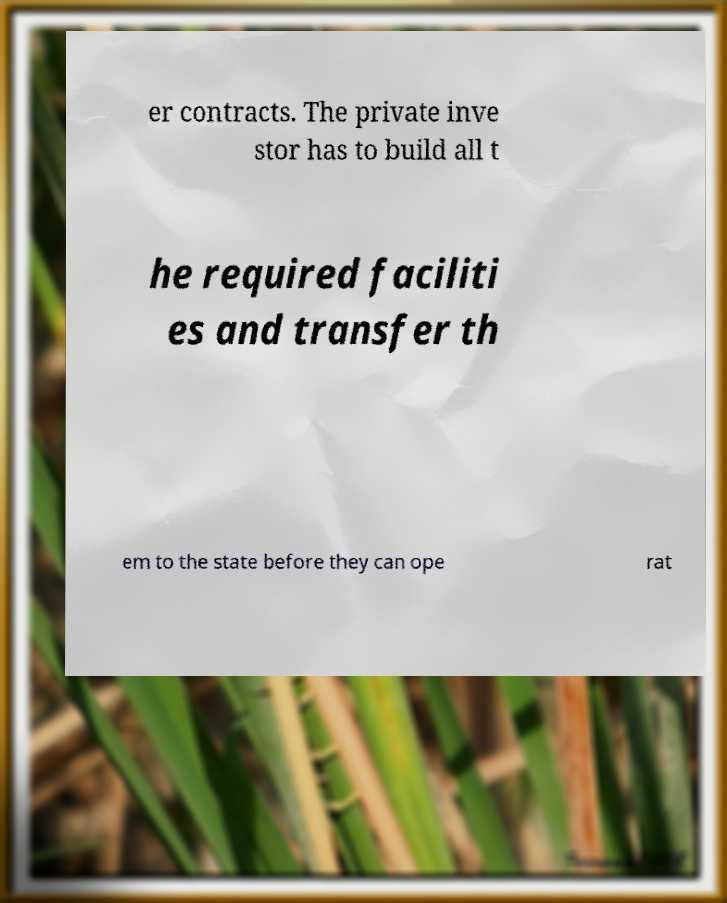For documentation purposes, I need the text within this image transcribed. Could you provide that? er contracts. The private inve stor has to build all t he required faciliti es and transfer th em to the state before they can ope rat 